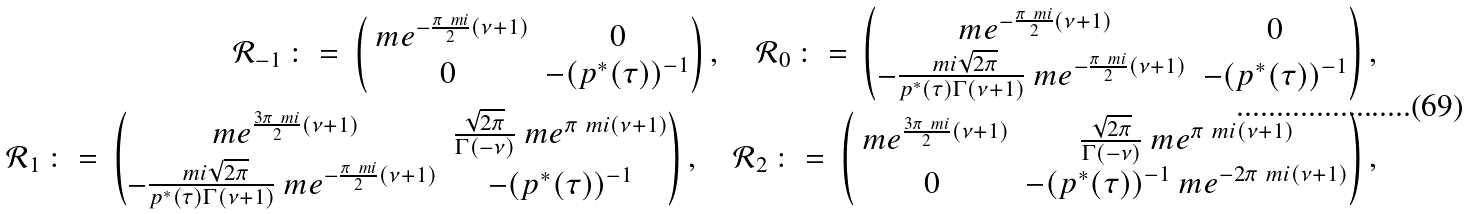Convert formula to latex. <formula><loc_0><loc_0><loc_500><loc_500>\mathcal { R } _ { - 1 } \, \colon = \, \begin{pmatrix} \ m e ^ { - \frac { \pi \ m i } { 2 } ( \nu + 1 ) } & 0 \\ 0 & - ( p ^ { \ast } ( \tau ) ) ^ { - 1 } \end{pmatrix} , \quad \mathcal { R } _ { 0 } \, \colon = \, \begin{pmatrix} \ m e ^ { - \frac { \pi \ m i } { 2 } ( \nu + 1 ) } & 0 \\ - \frac { \ m i \sqrt { 2 \pi } } { p ^ { \ast } ( \tau ) \Gamma ( \nu + 1 ) } \ m e ^ { - \frac { \pi \ m i } { 2 } ( \nu + 1 ) } & - ( p ^ { \ast } ( \tau ) ) ^ { - 1 } \end{pmatrix} , \\ \mathcal { R } _ { 1 } \, \colon = \, \begin{pmatrix} \ m e ^ { \frac { 3 \pi \ m i } { 2 } ( \nu + 1 ) } & \frac { \sqrt { 2 \pi } } { \Gamma ( - \nu ) } \ m e ^ { \pi \ m i ( \nu + 1 ) } \\ - \frac { \ m i \sqrt { 2 \pi } } { p ^ { \ast } ( \tau ) \Gamma ( \nu + 1 ) } \ m e ^ { - \frac { \pi \ m i } { 2 } ( \nu + 1 ) } & - ( p ^ { \ast } ( \tau ) ) ^ { - 1 } \end{pmatrix} , \quad \mathcal { R } _ { 2 } \, \colon = \, \begin{pmatrix} \ m e ^ { \frac { 3 \pi \ m i } { 2 } ( \nu + 1 ) } & \frac { \sqrt { 2 \pi } } { \Gamma ( - \nu ) } \ m e ^ { \pi \ m i ( \nu + 1 ) } \\ 0 & - ( p ^ { \ast } ( \tau ) ) ^ { - 1 } \ m e ^ { - 2 \pi \ m i ( \nu + 1 ) } \end{pmatrix} ,</formula> 